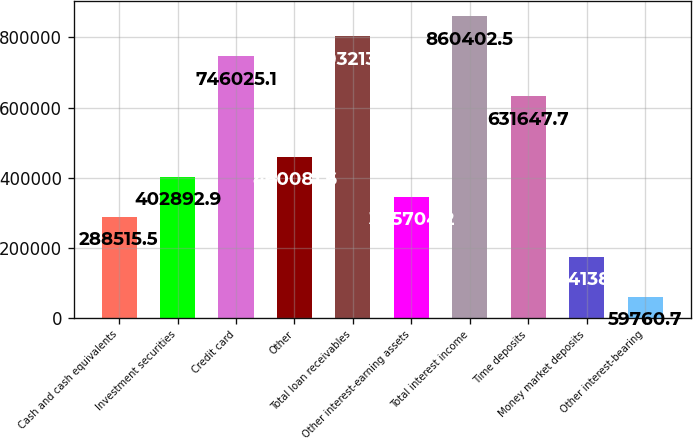Convert chart. <chart><loc_0><loc_0><loc_500><loc_500><bar_chart><fcel>Cash and cash equivalents<fcel>Investment securities<fcel>Credit card<fcel>Other<fcel>Total loan receivables<fcel>Other interest-earning assets<fcel>Total interest income<fcel>Time deposits<fcel>Money market deposits<fcel>Other interest-bearing<nl><fcel>288516<fcel>402893<fcel>746025<fcel>460082<fcel>803214<fcel>345704<fcel>860402<fcel>631648<fcel>174138<fcel>59760.7<nl></chart> 